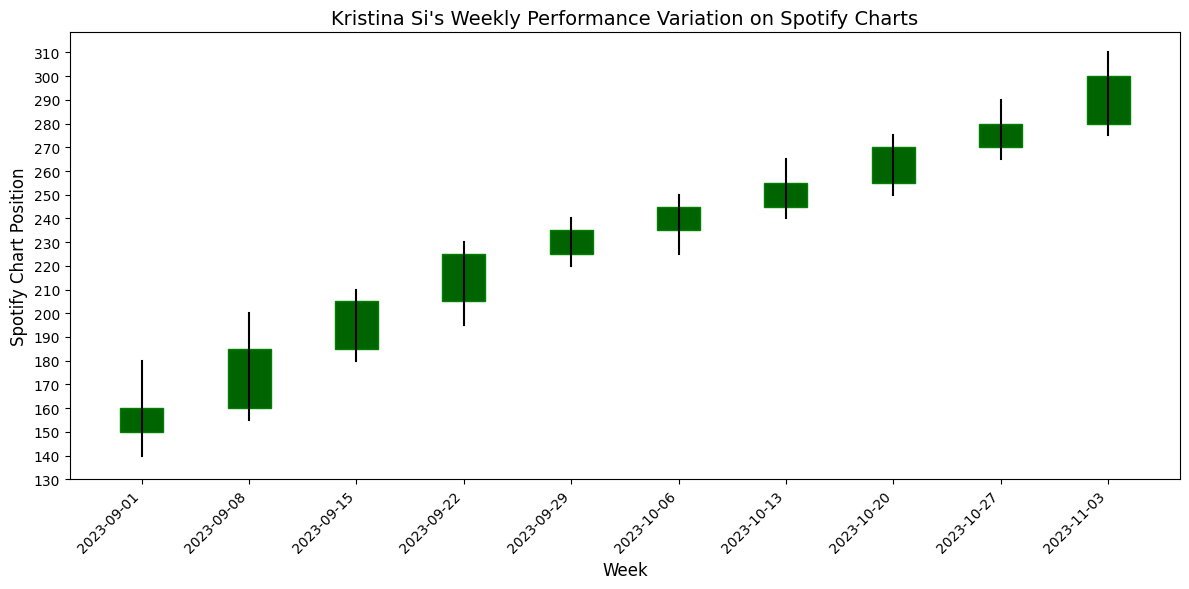What's the highest Spotify chart position reached by Kristina Si’s top songs in October 2023? In October 2023, the highest chart position can be found by looking for the maximum 'High' value in the weeks within October. Observing the chart, the highest position in October is 250, reached during the week of October 13th.
Answer: 250 Which week shows the most significant increase in closing position from the previous week? To determine the week with the most significant increase in closing position, calculate the difference between the closing positions of consecutive weeks. The week of September 08: (185 - 160) = 25, indicating the highest increase.
Answer: September 08 Did Kristina Si's top songs on Spotify charts ever experience a drop in closing position from one week to the next? By examining the closing positions in the chart, it is evident that there is no week where the closing position is lower than the previous week. Each subsequent week shows an increase or the same value. Therefore, there is no drop.
Answer: No What was the average opening position for Kristina Si's top songs in September 2023? To calculate the average opening position for September: (150 + 160 + 185 + 205 + 225) / 5. Adding these gives 925, and dividing by 5 gives 185.
Answer: 185 Compare the opening and closing positions for the week of November 03, 2023. What trend do you observe? For the week of November 03, the opening position is 280, and the closing position is 300. The trend observed is an upward movement as the closing position is higher than the opening position.
Answer: Upward Which week in October 2023 had the smallest difference between the high and low positions? By calculating the difference between high and low for each week in October: October 06 (250-225=25), October 13 (265-240=25), October 20 (275-250=25), October 27 (290-265=25). All weeks in October have the same difference of 25.
Answer: All weeks in October What's the general trend of Kristina Si's top songs on the Spotify charts from September 2023 to November 2023? Observing the chart, it’s clear that both high and low positions have increased consistently from September to November, indicating a steady rising trend in chart positions.
Answer: Rising Which week shows the highest single-week increase in the high position, and how much is this increase? The increase in high position is calculated by (next week high - current week high) for each pair of weeks. The highest increase is from October 20 (275) to October 27 (290), an increase of 15.
Answer: October 27, 15 With the given data, calculate the median closing position for September 2023. For September, the closing positions are 160, 185, 205, 225, 235. To find the median, they need to be ordered: 160, 185, 205, 225, 235. The middle value, or median, is 205.
Answer: 205 